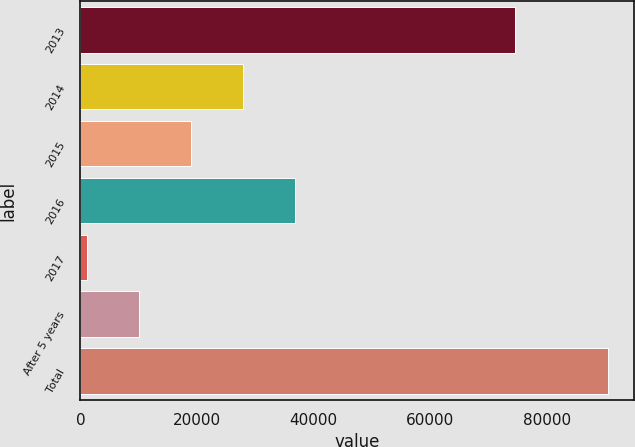Convert chart. <chart><loc_0><loc_0><loc_500><loc_500><bar_chart><fcel>2013<fcel>2014<fcel>2015<fcel>2016<fcel>2017<fcel>After 5 years<fcel>Total<nl><fcel>74469<fcel>27961.3<fcel>19039.2<fcel>36883.4<fcel>1195<fcel>10117.1<fcel>90416<nl></chart> 